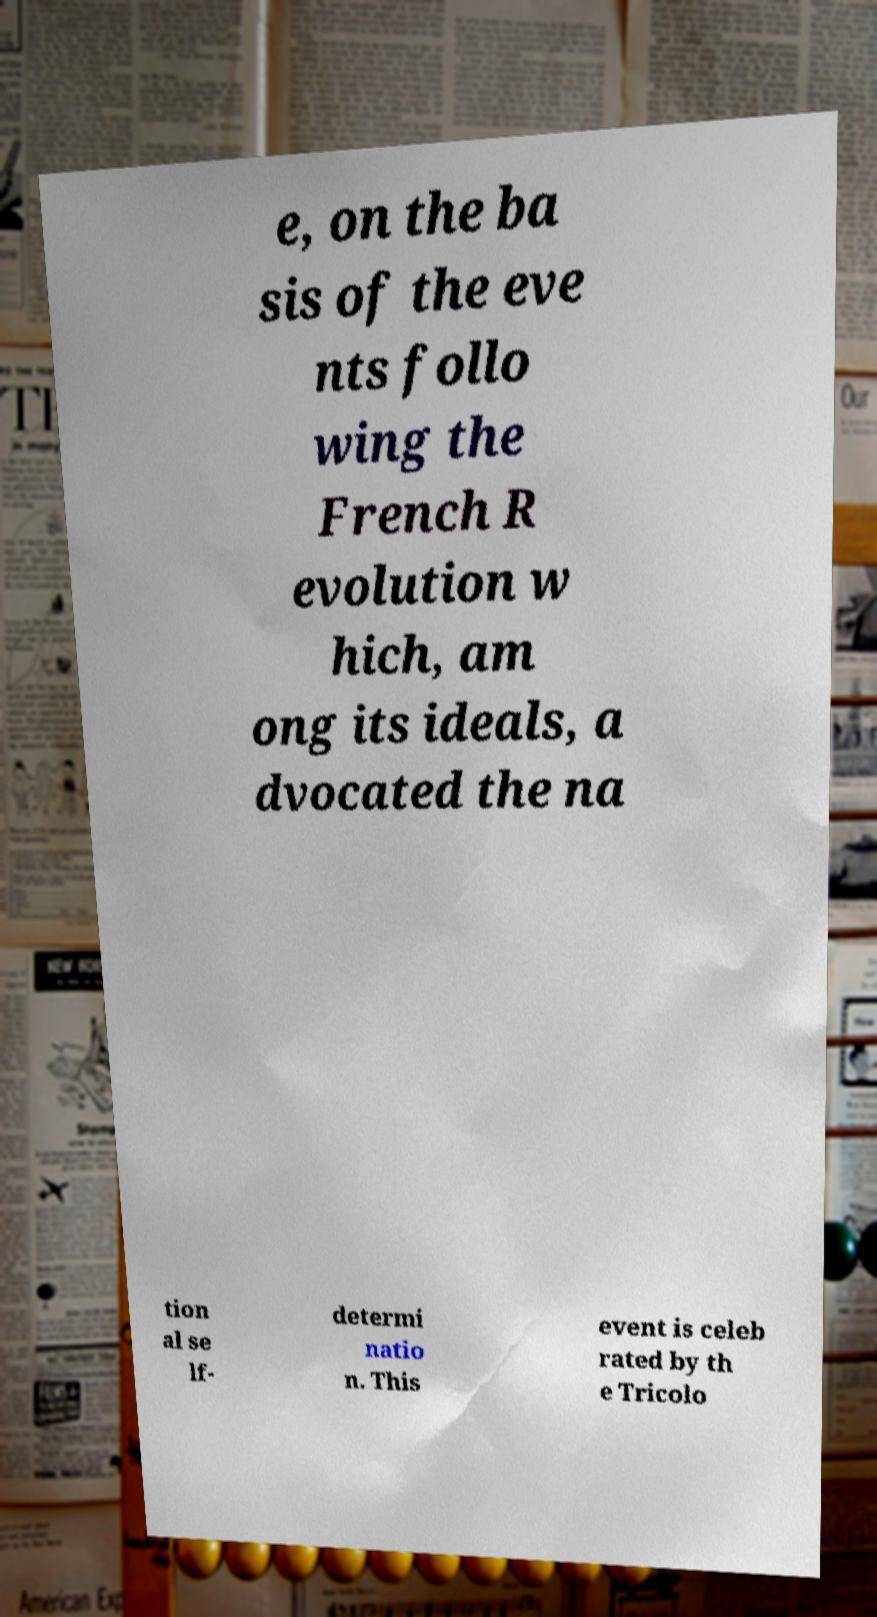Can you accurately transcribe the text from the provided image for me? e, on the ba sis of the eve nts follo wing the French R evolution w hich, am ong its ideals, a dvocated the na tion al se lf- determi natio n. This event is celeb rated by th e Tricolo 